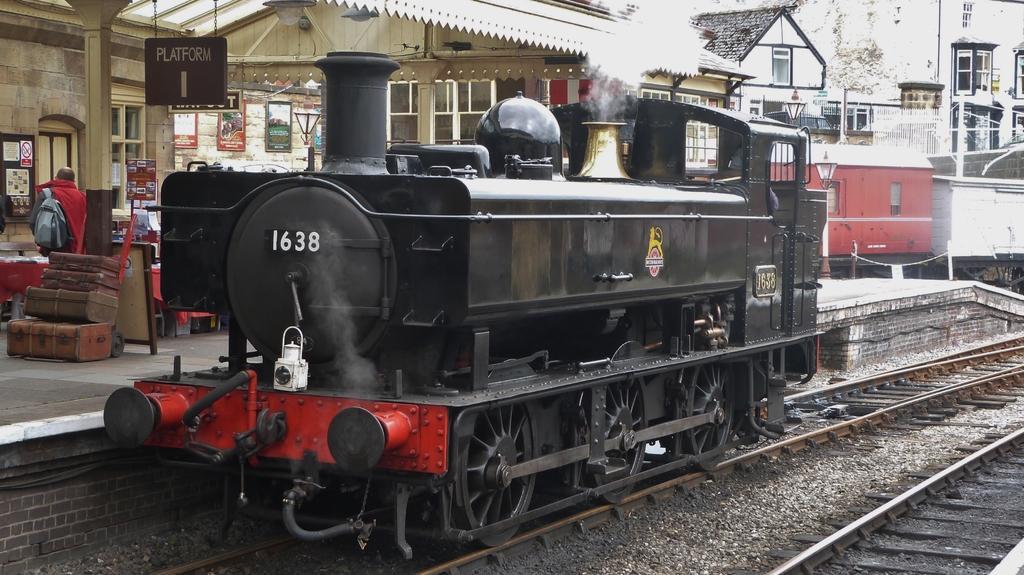How would you summarize this image in a sentence or two? This looks like a steam engine, which is on the railway track. Here is a platform. These are the luggage bags, which are placed one on the other. I can see a person standing. This looks like a board, which is hanging. I can see the houses with the windows. These are the frames, which are attached to the wall. I think this is a door. 